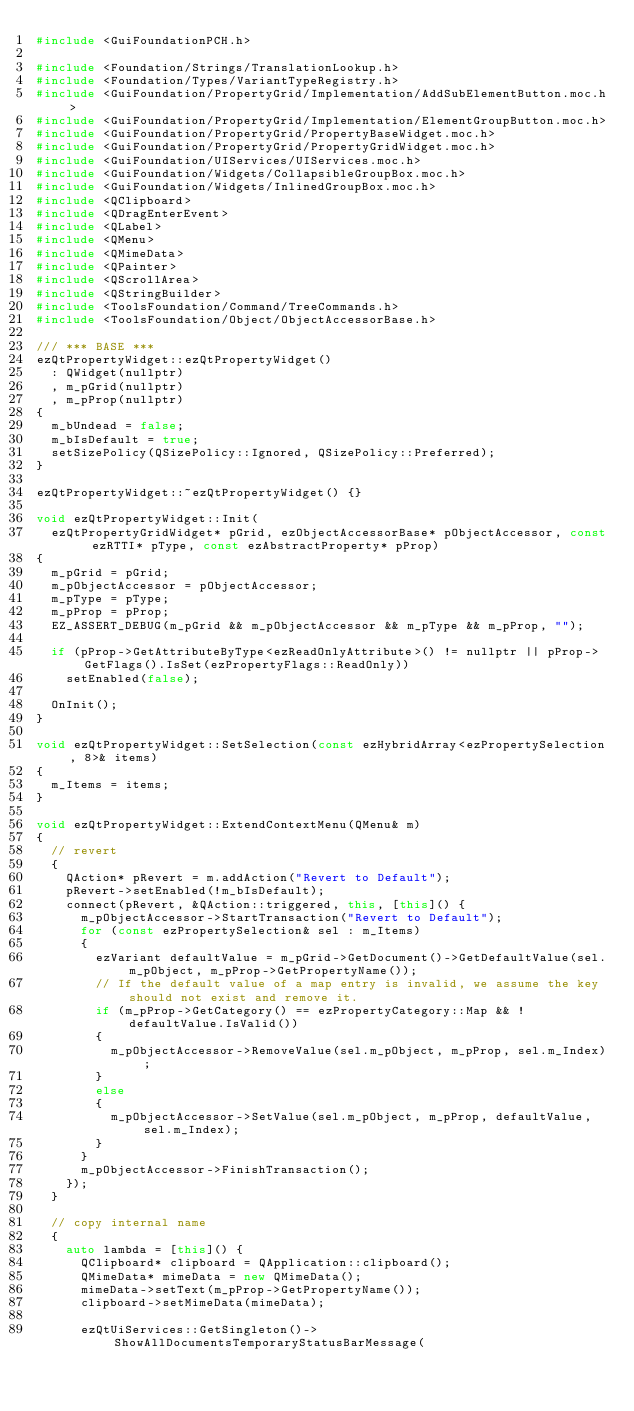Convert code to text. <code><loc_0><loc_0><loc_500><loc_500><_C++_>#include <GuiFoundationPCH.h>

#include <Foundation/Strings/TranslationLookup.h>
#include <Foundation/Types/VariantTypeRegistry.h>
#include <GuiFoundation/PropertyGrid/Implementation/AddSubElementButton.moc.h>
#include <GuiFoundation/PropertyGrid/Implementation/ElementGroupButton.moc.h>
#include <GuiFoundation/PropertyGrid/PropertyBaseWidget.moc.h>
#include <GuiFoundation/PropertyGrid/PropertyGridWidget.moc.h>
#include <GuiFoundation/UIServices/UIServices.moc.h>
#include <GuiFoundation/Widgets/CollapsibleGroupBox.moc.h>
#include <GuiFoundation/Widgets/InlinedGroupBox.moc.h>
#include <QClipboard>
#include <QDragEnterEvent>
#include <QLabel>
#include <QMenu>
#include <QMimeData>
#include <QPainter>
#include <QScrollArea>
#include <QStringBuilder>
#include <ToolsFoundation/Command/TreeCommands.h>
#include <ToolsFoundation/Object/ObjectAccessorBase.h>

/// *** BASE ***
ezQtPropertyWidget::ezQtPropertyWidget()
  : QWidget(nullptr)
  , m_pGrid(nullptr)
  , m_pProp(nullptr)
{
  m_bUndead = false;
  m_bIsDefault = true;
  setSizePolicy(QSizePolicy::Ignored, QSizePolicy::Preferred);
}

ezQtPropertyWidget::~ezQtPropertyWidget() {}

void ezQtPropertyWidget::Init(
  ezQtPropertyGridWidget* pGrid, ezObjectAccessorBase* pObjectAccessor, const ezRTTI* pType, const ezAbstractProperty* pProp)
{
  m_pGrid = pGrid;
  m_pObjectAccessor = pObjectAccessor;
  m_pType = pType;
  m_pProp = pProp;
  EZ_ASSERT_DEBUG(m_pGrid && m_pObjectAccessor && m_pType && m_pProp, "");

  if (pProp->GetAttributeByType<ezReadOnlyAttribute>() != nullptr || pProp->GetFlags().IsSet(ezPropertyFlags::ReadOnly))
    setEnabled(false);

  OnInit();
}

void ezQtPropertyWidget::SetSelection(const ezHybridArray<ezPropertySelection, 8>& items)
{
  m_Items = items;
}

void ezQtPropertyWidget::ExtendContextMenu(QMenu& m)
{
  // revert
  {
    QAction* pRevert = m.addAction("Revert to Default");
    pRevert->setEnabled(!m_bIsDefault);
    connect(pRevert, &QAction::triggered, this, [this]() {
      m_pObjectAccessor->StartTransaction("Revert to Default");
      for (const ezPropertySelection& sel : m_Items)
      {
        ezVariant defaultValue = m_pGrid->GetDocument()->GetDefaultValue(sel.m_pObject, m_pProp->GetPropertyName());
        // If the default value of a map entry is invalid, we assume the key should not exist and remove it.
        if (m_pProp->GetCategory() == ezPropertyCategory::Map && !defaultValue.IsValid())
        {
          m_pObjectAccessor->RemoveValue(sel.m_pObject, m_pProp, sel.m_Index);
        }
        else
        {
          m_pObjectAccessor->SetValue(sel.m_pObject, m_pProp, defaultValue, sel.m_Index);
        }
      }
      m_pObjectAccessor->FinishTransaction();
    });
  }

  // copy internal name
  {
    auto lambda = [this]() {
      QClipboard* clipboard = QApplication::clipboard();
      QMimeData* mimeData = new QMimeData();
      mimeData->setText(m_pProp->GetPropertyName());
      clipboard->setMimeData(mimeData);

      ezQtUiServices::GetSingleton()->ShowAllDocumentsTemporaryStatusBarMessage(</code> 